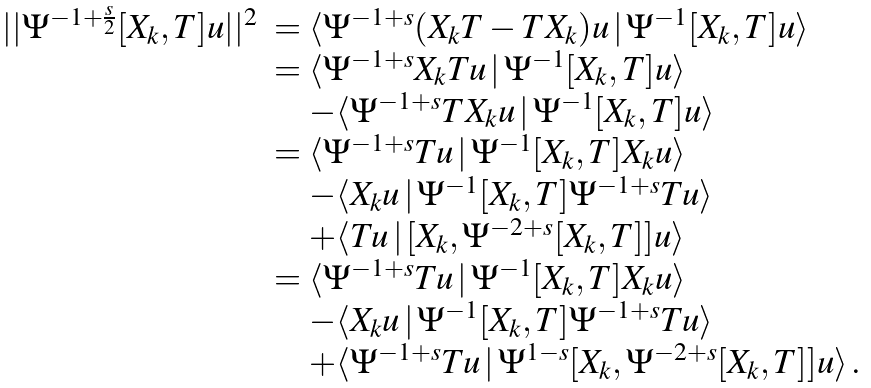<formula> <loc_0><loc_0><loc_500><loc_500>\begin{array} { l l } | | \Psi ^ { - 1 + \frac { s } { 2 } } [ X _ { k } , T ] u | | ^ { 2 } & = \langle \Psi ^ { - 1 + s } ( X _ { k } T - T X _ { k } ) u \, | \, \Psi ^ { - 1 } [ X _ { k } , T ] u \rangle \\ & = \langle \Psi ^ { - 1 + s } X _ { k } T u \, | \, \Psi ^ { - 1 } [ X _ { k } , T ] u \rangle \\ & \quad - \langle \Psi ^ { - 1 + s } T X _ { k } u \, | \, \Psi ^ { - 1 } [ X _ { k } , T ] u \rangle \\ & = \langle \Psi ^ { - 1 + s } T u \, | \, \Psi ^ { - 1 } [ X _ { k } , T ] X _ { k } u \rangle \\ & \quad - \langle X _ { k } u \, | \, \Psi ^ { - 1 } [ X _ { k } , T ] \Psi ^ { - 1 + s } T u \rangle \\ & \quad + \langle T u \, | \, [ X _ { k } , \Psi ^ { - 2 + s } [ X _ { k } , T ] ] u \rangle \\ & = \langle \Psi ^ { - 1 + s } T u \, | \, \Psi ^ { - 1 } [ X _ { k } , T ] X _ { k } u \rangle \\ & \quad - \langle X _ { k } u \, | \, \Psi ^ { - 1 } [ X _ { k } , T ] \Psi ^ { - 1 + s } T u \rangle \\ & \quad + \langle \Psi ^ { - 1 + s } T u \, | \, \Psi ^ { 1 - s } [ X _ { k } , \Psi ^ { - 2 + s } [ X _ { k } , T ] ] u \rangle \, . \end{array}</formula> 